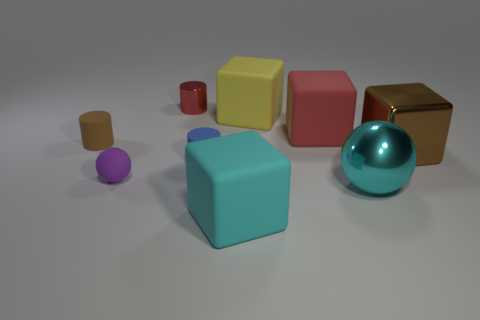What is the brown thing right of the cyan rubber cube made of?
Offer a terse response. Metal. What number of objects are either tiny yellow rubber cylinders or rubber cubes on the left side of the yellow rubber thing?
Your answer should be compact. 1. There is a brown rubber thing that is the same size as the blue thing; what is its shape?
Offer a terse response. Cylinder. How many rubber things are the same color as the small metal object?
Ensure brevity in your answer.  1. Is the material of the red thing that is behind the big yellow cube the same as the large brown block?
Provide a succinct answer. Yes. What is the shape of the tiny brown object?
Your answer should be compact. Cylinder. What number of brown things are either large metallic blocks or large spheres?
Make the answer very short. 1. How many other things are there of the same material as the big cyan cube?
Give a very brief answer. 5. Does the big rubber thing that is in front of the big brown metal object have the same shape as the large brown object?
Ensure brevity in your answer.  Yes. Is there a big cyan metal sphere?
Provide a short and direct response. Yes. 